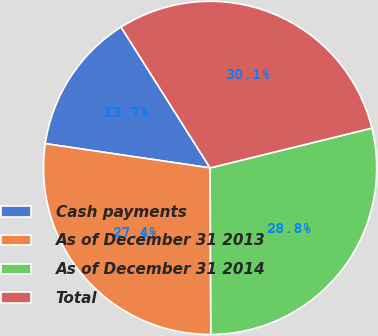<chart> <loc_0><loc_0><loc_500><loc_500><pie_chart><fcel>Cash payments<fcel>As of December 31 2013<fcel>As of December 31 2014<fcel>Total<nl><fcel>13.7%<fcel>27.4%<fcel>28.77%<fcel>30.14%<nl></chart> 